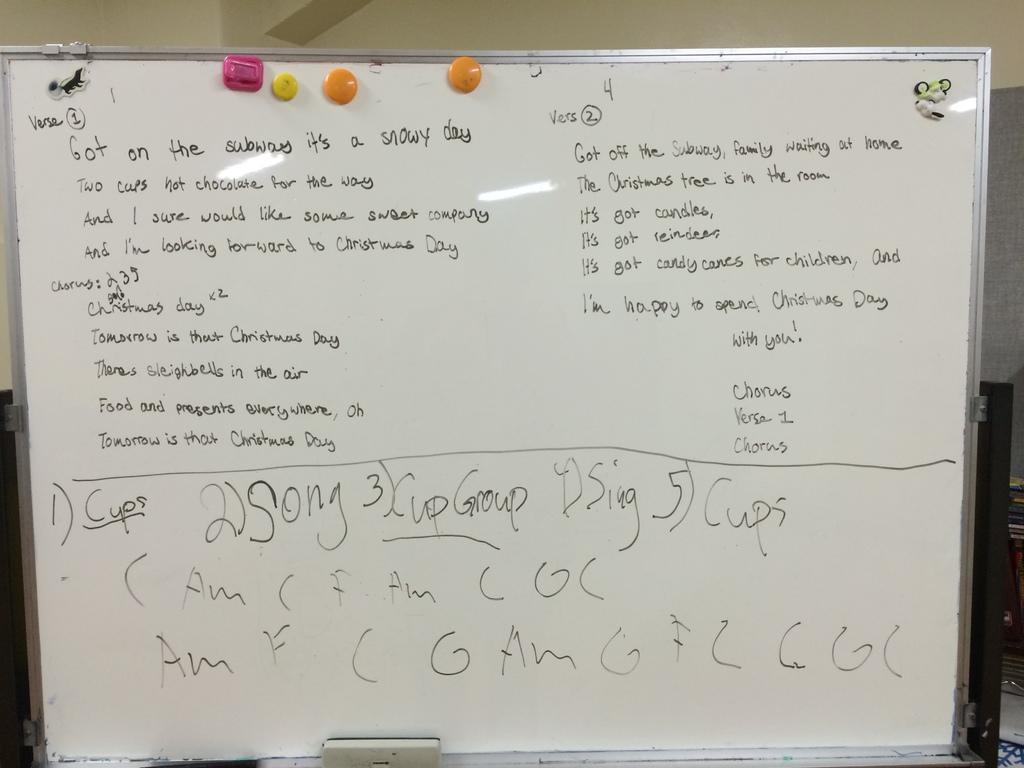<image>
Give a short and clear explanation of the subsequent image. A white board has Verse 1 written in the top corner. 